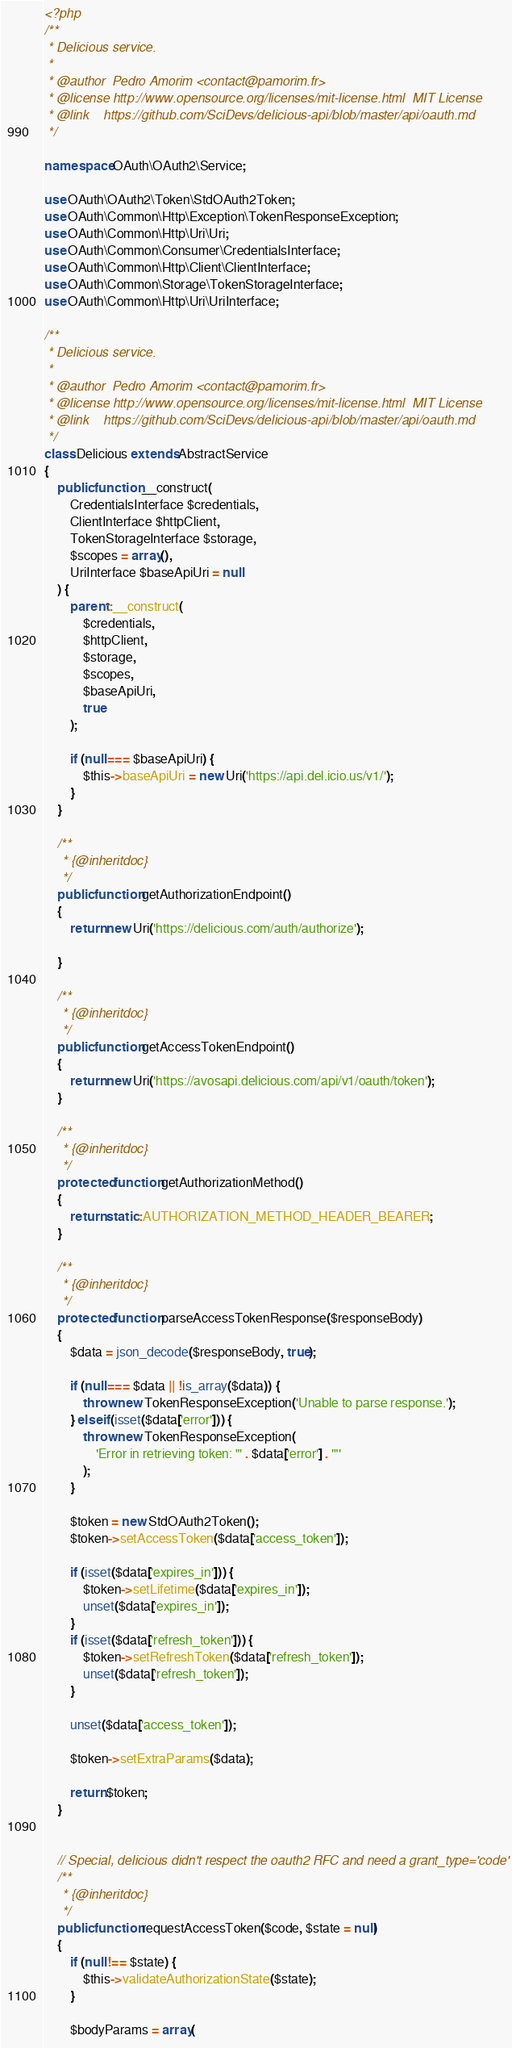<code> <loc_0><loc_0><loc_500><loc_500><_PHP_><?php
/**
 * Delicious service.
 *
 * @author  Pedro Amorim <contact@pamorim.fr>
 * @license http://www.opensource.org/licenses/mit-license.html  MIT License
 * @link    https://github.com/SciDevs/delicious-api/blob/master/api/oauth.md
 */

namespace OAuth\OAuth2\Service;

use OAuth\OAuth2\Token\StdOAuth2Token;
use OAuth\Common\Http\Exception\TokenResponseException;
use OAuth\Common\Http\Uri\Uri;
use OAuth\Common\Consumer\CredentialsInterface;
use OAuth\Common\Http\Client\ClientInterface;
use OAuth\Common\Storage\TokenStorageInterface;
use OAuth\Common\Http\Uri\UriInterface;

/**
 * Delicious service.
 *
 * @author  Pedro Amorim <contact@pamorim.fr>
 * @license http://www.opensource.org/licenses/mit-license.html  MIT License
 * @link    https://github.com/SciDevs/delicious-api/blob/master/api/oauth.md
 */
class Delicious extends AbstractService
{
    public function __construct(
        CredentialsInterface $credentials,
        ClientInterface $httpClient,
        TokenStorageInterface $storage,
        $scopes = array(),
        UriInterface $baseApiUri = null
    ) {
        parent::__construct(
            $credentials,
            $httpClient,
            $storage,
            $scopes,
            $baseApiUri,
            true
        );

        if (null === $baseApiUri) {
            $this->baseApiUri = new Uri('https://api.del.icio.us/v1/');
        }
    }

    /**
     * {@inheritdoc}
     */
    public function getAuthorizationEndpoint()
    {
        return new Uri('https://delicious.com/auth/authorize');

    }

    /**
     * {@inheritdoc}
     */
    public function getAccessTokenEndpoint()
    {
        return new Uri('https://avosapi.delicious.com/api/v1/oauth/token');
    }

    /**
     * {@inheritdoc}
     */
    protected function getAuthorizationMethod()
    {
        return static::AUTHORIZATION_METHOD_HEADER_BEARER;
    }

    /**
     * {@inheritdoc}
     */
    protected function parseAccessTokenResponse($responseBody)
    {
        $data = json_decode($responseBody, true);

        if (null === $data || !is_array($data)) {
            throw new TokenResponseException('Unable to parse response.');
        } elseif (isset($data['error'])) {
            throw new TokenResponseException(
                'Error in retrieving token: "' . $data['error'] . '"'
            );
        }

        $token = new StdOAuth2Token();
        $token->setAccessToken($data['access_token']);

        if (isset($data['expires_in'])) {
            $token->setLifetime($data['expires_in']);
            unset($data['expires_in']);
        }
        if (isset($data['refresh_token'])) {
            $token->setRefreshToken($data['refresh_token']);
            unset($data['refresh_token']);
        }

        unset($data['access_token']);

        $token->setExtraParams($data);

        return $token;
    }


    // Special, delicious didn't respect the oauth2 RFC and need a grant_type='code'
    /**
     * {@inheritdoc}
     */
    public function requestAccessToken($code, $state = null)
    {
        if (null !== $state) {
            $this->validateAuthorizationState($state);
        }

        $bodyParams = array(</code> 